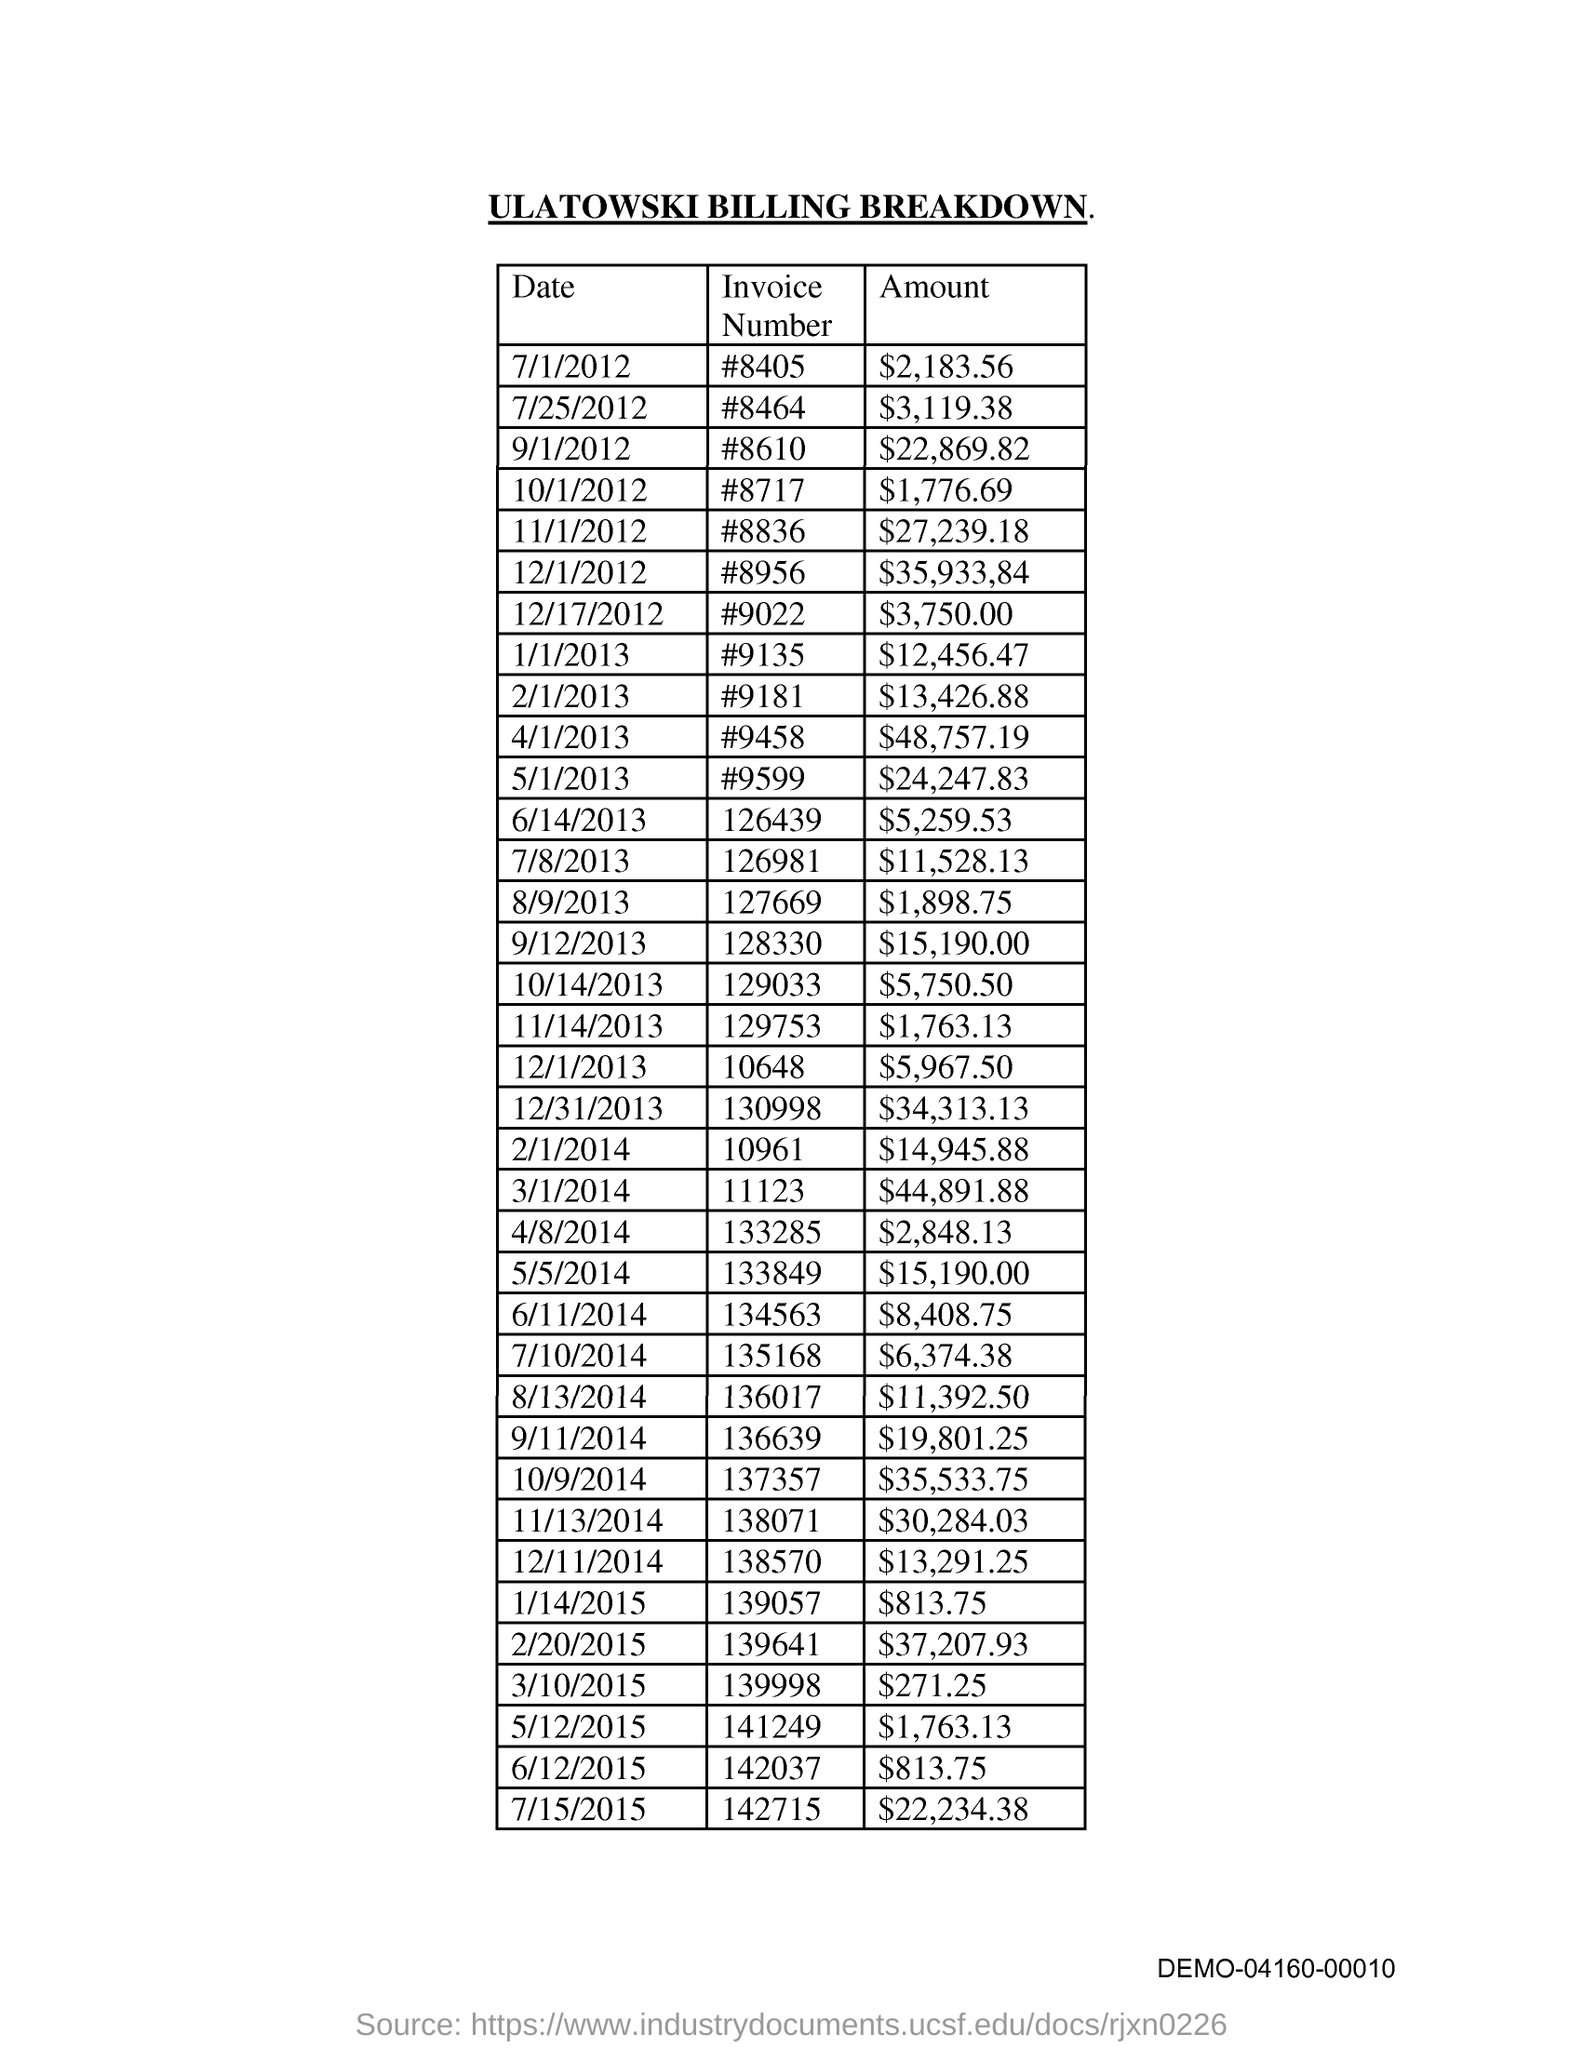What is the title of the document?
Make the answer very short. Ulatowski Billing Breakdown. 